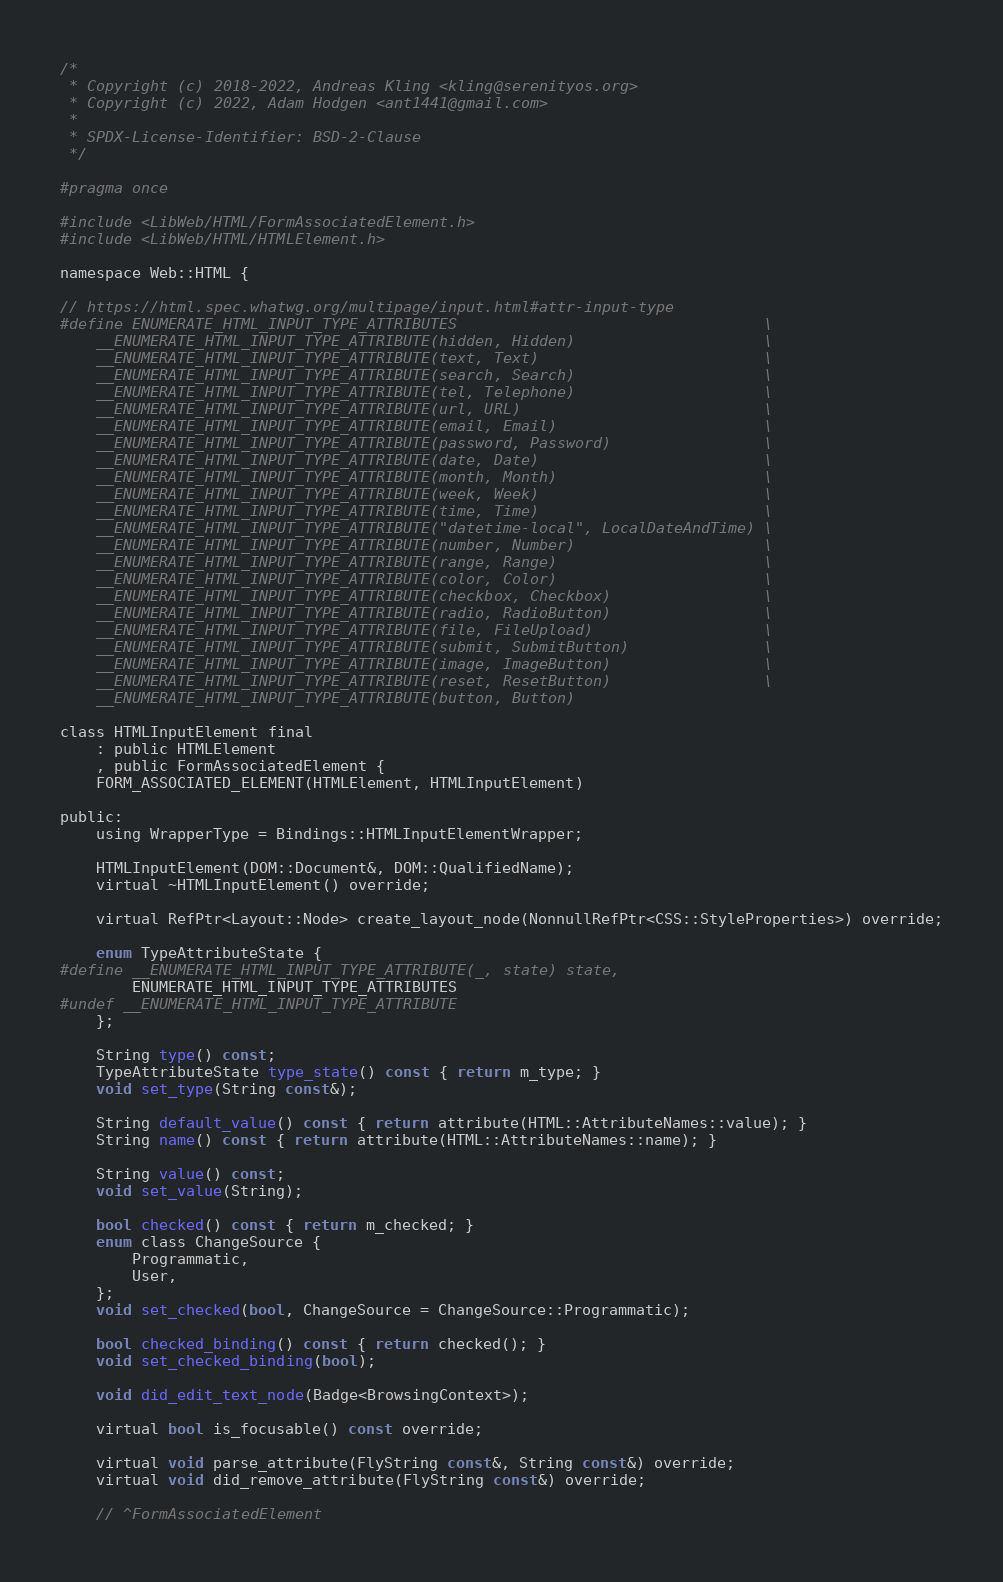<code> <loc_0><loc_0><loc_500><loc_500><_C_>/*
 * Copyright (c) 2018-2022, Andreas Kling <kling@serenityos.org>
 * Copyright (c) 2022, Adam Hodgen <ant1441@gmail.com>
 *
 * SPDX-License-Identifier: BSD-2-Clause
 */

#pragma once

#include <LibWeb/HTML/FormAssociatedElement.h>
#include <LibWeb/HTML/HTMLElement.h>

namespace Web::HTML {

// https://html.spec.whatwg.org/multipage/input.html#attr-input-type
#define ENUMERATE_HTML_INPUT_TYPE_ATTRIBUTES                                  \
    __ENUMERATE_HTML_INPUT_TYPE_ATTRIBUTE(hidden, Hidden)                     \
    __ENUMERATE_HTML_INPUT_TYPE_ATTRIBUTE(text, Text)                         \
    __ENUMERATE_HTML_INPUT_TYPE_ATTRIBUTE(search, Search)                     \
    __ENUMERATE_HTML_INPUT_TYPE_ATTRIBUTE(tel, Telephone)                     \
    __ENUMERATE_HTML_INPUT_TYPE_ATTRIBUTE(url, URL)                           \
    __ENUMERATE_HTML_INPUT_TYPE_ATTRIBUTE(email, Email)                       \
    __ENUMERATE_HTML_INPUT_TYPE_ATTRIBUTE(password, Password)                 \
    __ENUMERATE_HTML_INPUT_TYPE_ATTRIBUTE(date, Date)                         \
    __ENUMERATE_HTML_INPUT_TYPE_ATTRIBUTE(month, Month)                       \
    __ENUMERATE_HTML_INPUT_TYPE_ATTRIBUTE(week, Week)                         \
    __ENUMERATE_HTML_INPUT_TYPE_ATTRIBUTE(time, Time)                         \
    __ENUMERATE_HTML_INPUT_TYPE_ATTRIBUTE("datetime-local", LocalDateAndTime) \
    __ENUMERATE_HTML_INPUT_TYPE_ATTRIBUTE(number, Number)                     \
    __ENUMERATE_HTML_INPUT_TYPE_ATTRIBUTE(range, Range)                       \
    __ENUMERATE_HTML_INPUT_TYPE_ATTRIBUTE(color, Color)                       \
    __ENUMERATE_HTML_INPUT_TYPE_ATTRIBUTE(checkbox, Checkbox)                 \
    __ENUMERATE_HTML_INPUT_TYPE_ATTRIBUTE(radio, RadioButton)                 \
    __ENUMERATE_HTML_INPUT_TYPE_ATTRIBUTE(file, FileUpload)                   \
    __ENUMERATE_HTML_INPUT_TYPE_ATTRIBUTE(submit, SubmitButton)               \
    __ENUMERATE_HTML_INPUT_TYPE_ATTRIBUTE(image, ImageButton)                 \
    __ENUMERATE_HTML_INPUT_TYPE_ATTRIBUTE(reset, ResetButton)                 \
    __ENUMERATE_HTML_INPUT_TYPE_ATTRIBUTE(button, Button)

class HTMLInputElement final
    : public HTMLElement
    , public FormAssociatedElement {
    FORM_ASSOCIATED_ELEMENT(HTMLElement, HTMLInputElement)

public:
    using WrapperType = Bindings::HTMLInputElementWrapper;

    HTMLInputElement(DOM::Document&, DOM::QualifiedName);
    virtual ~HTMLInputElement() override;

    virtual RefPtr<Layout::Node> create_layout_node(NonnullRefPtr<CSS::StyleProperties>) override;

    enum TypeAttributeState {
#define __ENUMERATE_HTML_INPUT_TYPE_ATTRIBUTE(_, state) state,
        ENUMERATE_HTML_INPUT_TYPE_ATTRIBUTES
#undef __ENUMERATE_HTML_INPUT_TYPE_ATTRIBUTE
    };

    String type() const;
    TypeAttributeState type_state() const { return m_type; }
    void set_type(String const&);

    String default_value() const { return attribute(HTML::AttributeNames::value); }
    String name() const { return attribute(HTML::AttributeNames::name); }

    String value() const;
    void set_value(String);

    bool checked() const { return m_checked; }
    enum class ChangeSource {
        Programmatic,
        User,
    };
    void set_checked(bool, ChangeSource = ChangeSource::Programmatic);

    bool checked_binding() const { return checked(); }
    void set_checked_binding(bool);

    void did_edit_text_node(Badge<BrowsingContext>);

    virtual bool is_focusable() const override;

    virtual void parse_attribute(FlyString const&, String const&) override;
    virtual void did_remove_attribute(FlyString const&) override;

    // ^FormAssociatedElement</code> 